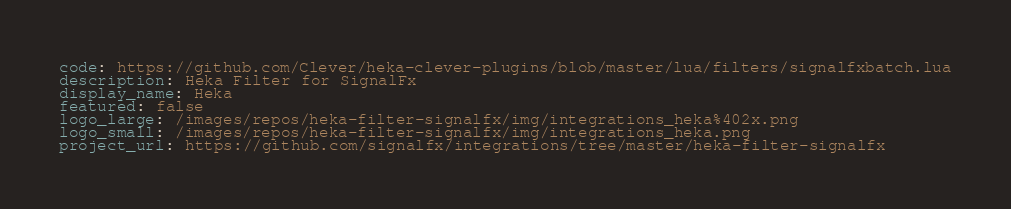Convert code to text. <code><loc_0><loc_0><loc_500><loc_500><_YAML_>code: https://github.com/Clever/heka-clever-plugins/blob/master/lua/filters/signalfxbatch.lua
description: Heka Filter for SignalFx
display_name: Heka
featured: false
logo_large: /images/repos/heka-filter-signalfx/img/integrations_heka%402x.png
logo_small: /images/repos/heka-filter-signalfx/img/integrations_heka.png
project_url: https://github.com/signalfx/integrations/tree/master/heka-filter-signalfx
</code> 